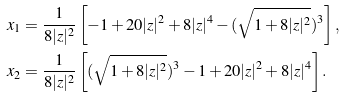Convert formula to latex. <formula><loc_0><loc_0><loc_500><loc_500>x _ { 1 } & = \frac { 1 } { 8 | z | ^ { 2 } } \left [ - 1 + 2 0 | z | ^ { 2 } + 8 | z | ^ { 4 } - ( \sqrt { 1 + 8 | z | ^ { 2 } } ) ^ { 3 } \right ] , \\ x _ { 2 } & = \frac { 1 } { 8 | z | ^ { 2 } } \left [ ( \sqrt { 1 + 8 | z | ^ { 2 } } ) ^ { 3 } - 1 + 2 0 | z | ^ { 2 } + 8 | z | ^ { 4 } \right ] .</formula> 